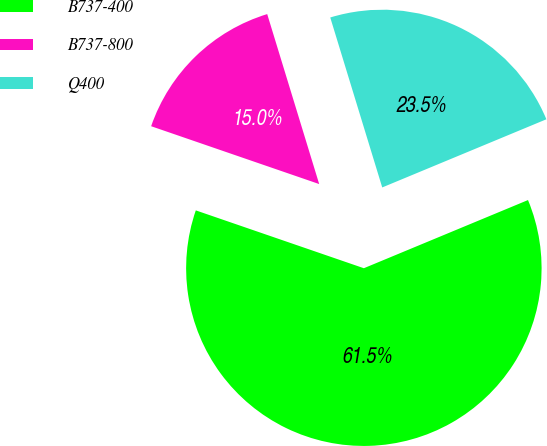Convert chart. <chart><loc_0><loc_0><loc_500><loc_500><pie_chart><fcel>B737-400<fcel>B737-800<fcel>Q400<nl><fcel>61.54%<fcel>15.0%<fcel>23.46%<nl></chart> 